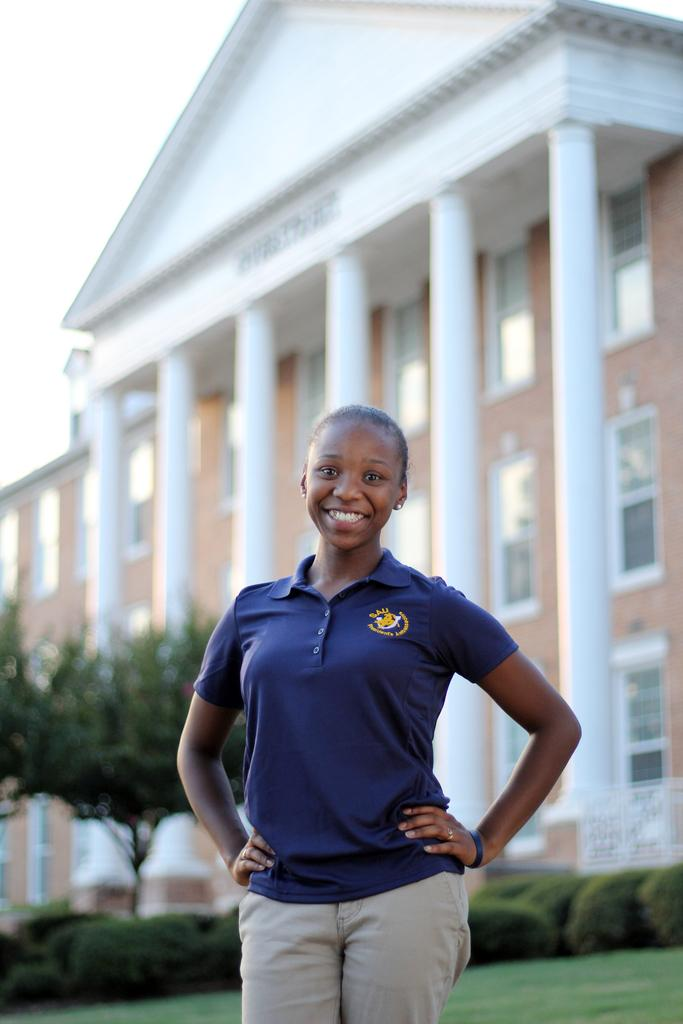What is the woman in the image doing? The woman is standing in the image and smiling. What can be seen in the image besides the woman? There are plants, grass, a tree, and a building in the background of the image. What type of vegetation is present in the image? The image contains plants, grass, and a tree. What type of vegetable is being harvested by the cattle in the image? There are no cattle or vegetables present in the image. Can you see a boot on the woman's foot in the image? The image does not show the woman's foot or any boots. 